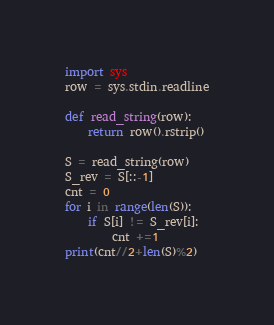Convert code to text. <code><loc_0><loc_0><loc_500><loc_500><_Python_>
import sys
row = sys.stdin.readline

def read_string(row):
    return row().rstrip()
  
S = read_string(row)
S_rev = S[::-1]
cnt = 0
for i in range(len(S)):
    if S[i] != S_rev[i]:
        cnt +=1
print(cnt//2+len(S)%2)</code> 